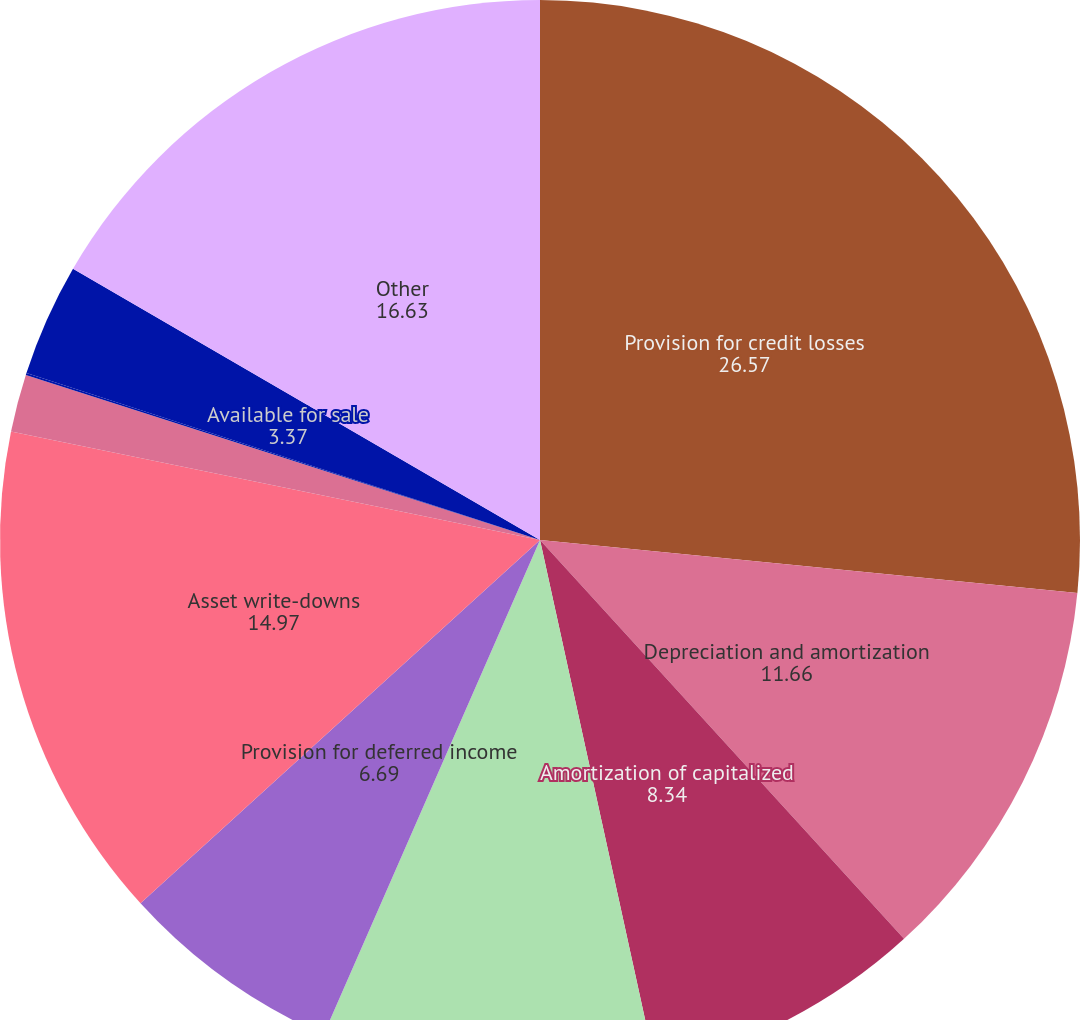Convert chart. <chart><loc_0><loc_0><loc_500><loc_500><pie_chart><fcel>Provision for credit losses<fcel>Depreciation and amortization<fcel>Amortization of capitalized<fcel>Amortization of core deposit<fcel>Provision for deferred income<fcel>Asset write-downs<fcel>Net gain on sales of assets<fcel>Net change in accrued interest<fcel>Available for sale<fcel>Other<nl><fcel>26.57%<fcel>11.66%<fcel>8.34%<fcel>10.0%<fcel>6.69%<fcel>14.97%<fcel>1.72%<fcel>0.06%<fcel>3.37%<fcel>16.63%<nl></chart> 